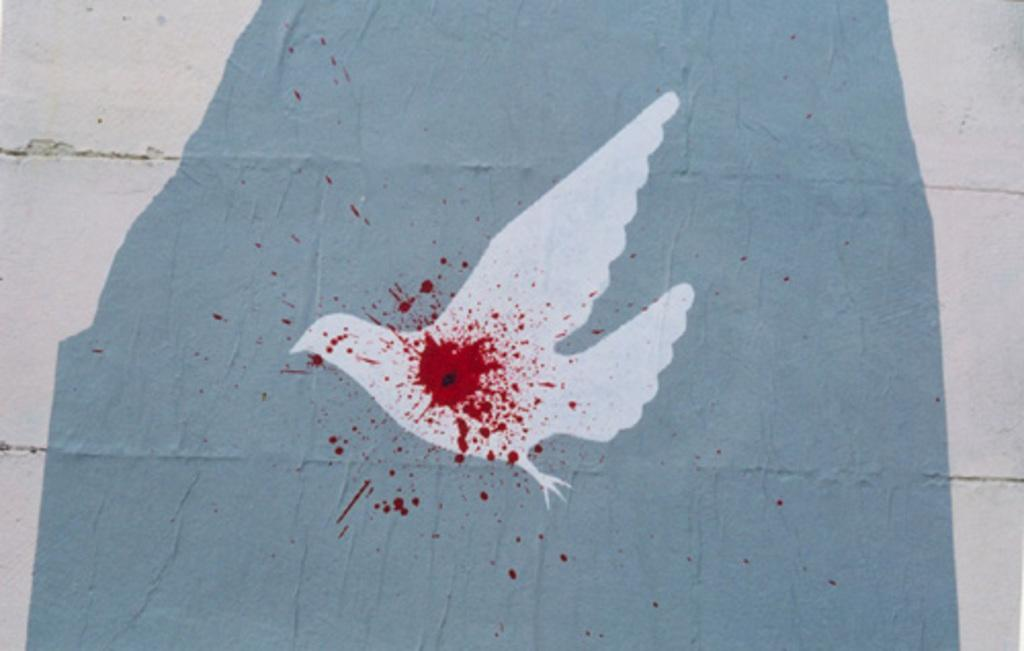What is the main subject of the painting in the image? The painting depicts a bird. Are there any notable features of the bird in the painting? Yes, the bird in the painting has blood marks. Where is the painting located in the image? The painting is on a wall. What plot is the bird in the painting trying to convey to the viewer? The painting is not a living entity and therefore cannot convey a plot. Is there a letter addressed to the viewer's aunt in the image? There is no letter or reference to an aunt in the image. 